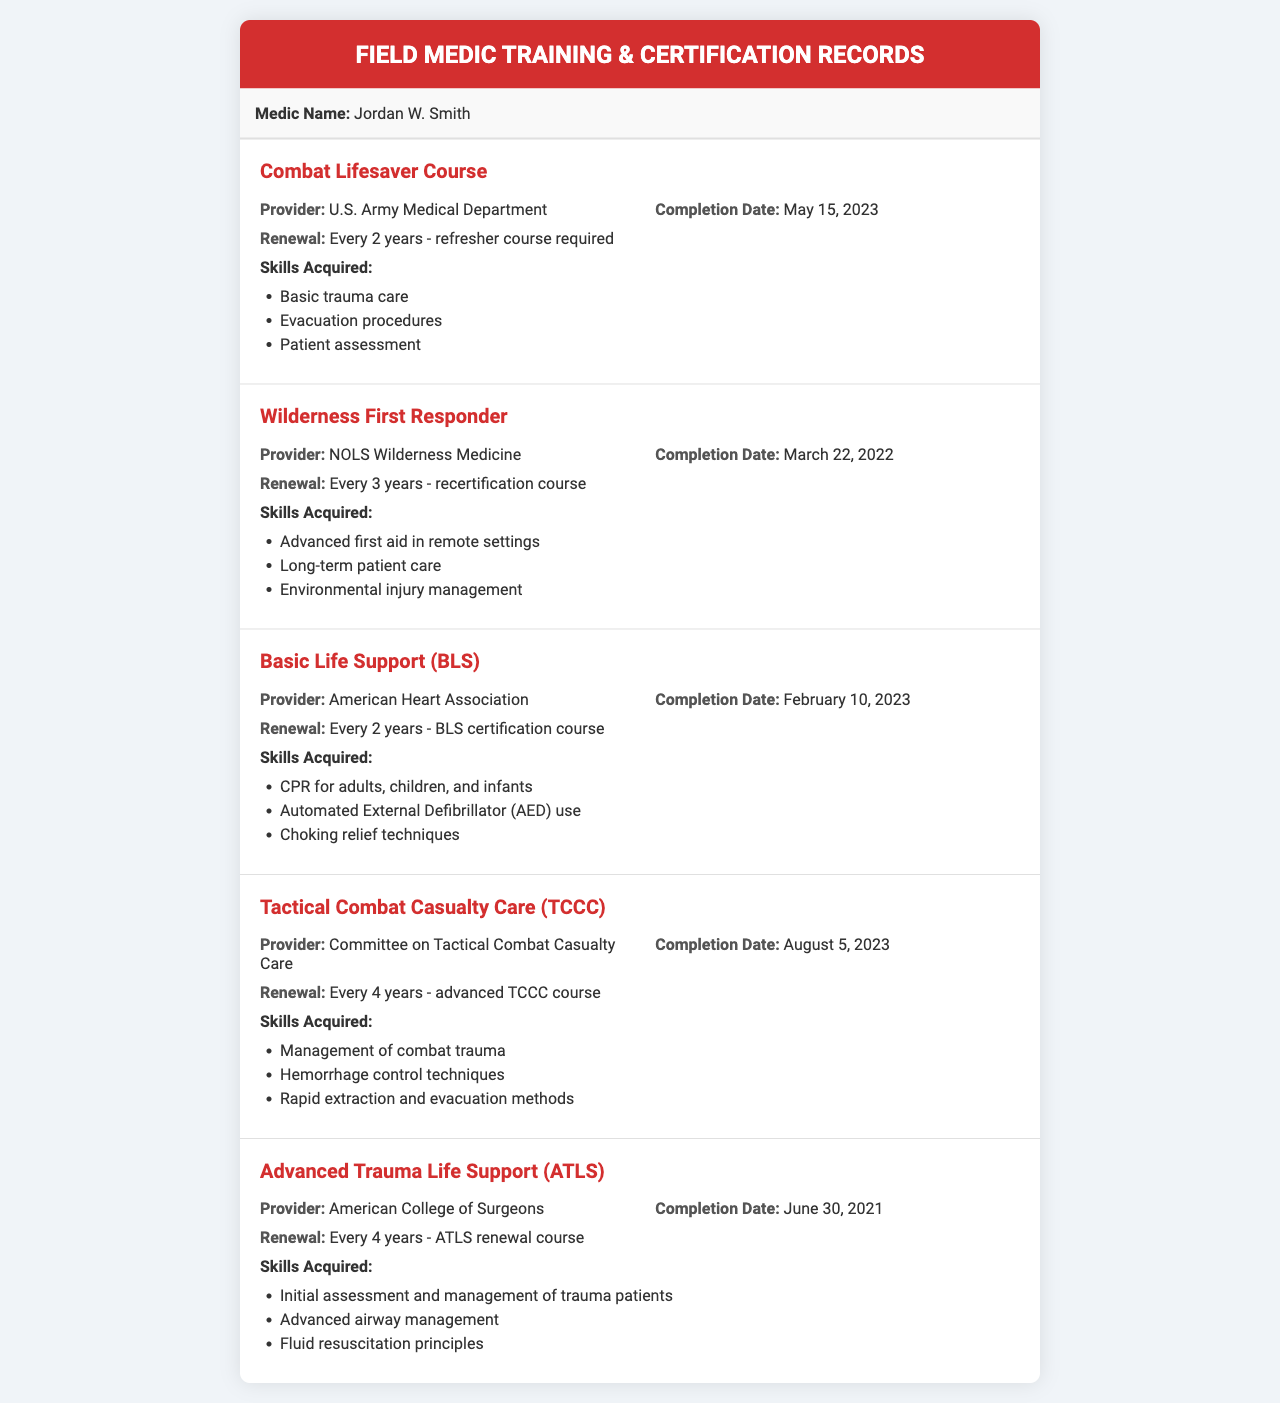What is the name of the medic? The document provides the medic's name at the beginning, which is mentioned in the medic-info section.
Answer: Jordan W. Smith When was the completion date for the Combat Lifesaver Course? The completion date is provided within the training record for the Combat Lifesaver Course.
Answer: May 15, 2023 How often does the Wilderness First Responder certification need to be renewed? The renewal requirement is listed in the details section of the Wilderness First Responder training record.
Answer: Every 3 years - recertification course Which provider offered the Basic Life Support course? The provider information is specified in the details of the Basic Life Support training record.
Answer: American Heart Association What skills are acquired from the Tactical Combat Casualty Care course? The skills acquired are listed in the training record for Tactical Combat Casualty Care and can be found in a bullet list format.
Answer: Management of combat trauma, Hemorrhage control techniques, Rapid extraction and evacuation methods How long is the renewal period for the Advanced Trauma Life Support course? The renewal period is found in the details of the Advanced Trauma Life Support training record.
Answer: Every 4 years - ATLS renewal course What date was the Wilderness First Responder course completed? The completion date can be found in the details section of the Wilderness First Responder training record.
Answer: March 22, 2022 Who is the provider for the Tactical Combat Casualty Care course? The provider name is stated in the details of the Tactical Combat Casualty Care training record.
Answer: Committee on Tactical Combat Casualty Care 